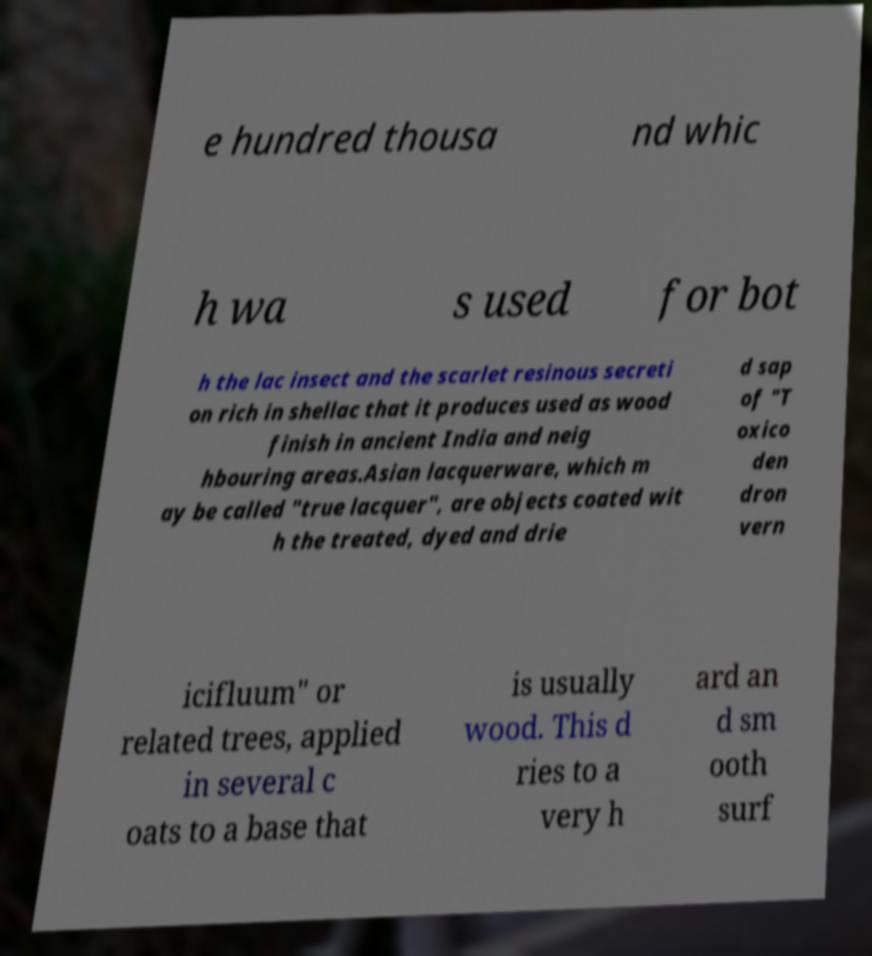Could you extract and type out the text from this image? e hundred thousa nd whic h wa s used for bot h the lac insect and the scarlet resinous secreti on rich in shellac that it produces used as wood finish in ancient India and neig hbouring areas.Asian lacquerware, which m ay be called "true lacquer", are objects coated wit h the treated, dyed and drie d sap of "T oxico den dron vern icifluum" or related trees, applied in several c oats to a base that is usually wood. This d ries to a very h ard an d sm ooth surf 